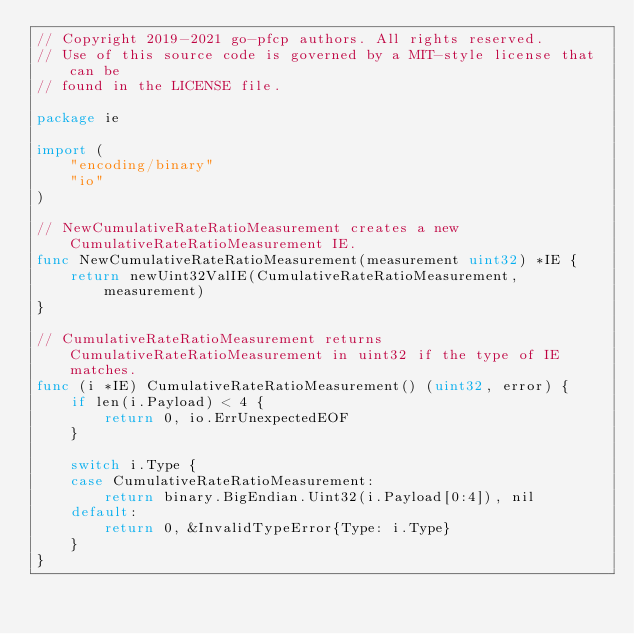<code> <loc_0><loc_0><loc_500><loc_500><_Go_>// Copyright 2019-2021 go-pfcp authors. All rights reserved.
// Use of this source code is governed by a MIT-style license that can be
// found in the LICENSE file.

package ie

import (
	"encoding/binary"
	"io"
)

// NewCumulativeRateRatioMeasurement creates a new CumulativeRateRatioMeasurement IE.
func NewCumulativeRateRatioMeasurement(measurement uint32) *IE {
	return newUint32ValIE(CumulativeRateRatioMeasurement, measurement)
}

// CumulativeRateRatioMeasurement returns CumulativeRateRatioMeasurement in uint32 if the type of IE matches.
func (i *IE) CumulativeRateRatioMeasurement() (uint32, error) {
	if len(i.Payload) < 4 {
		return 0, io.ErrUnexpectedEOF
	}

	switch i.Type {
	case CumulativeRateRatioMeasurement:
		return binary.BigEndian.Uint32(i.Payload[0:4]), nil
	default:
		return 0, &InvalidTypeError{Type: i.Type}
	}
}
</code> 